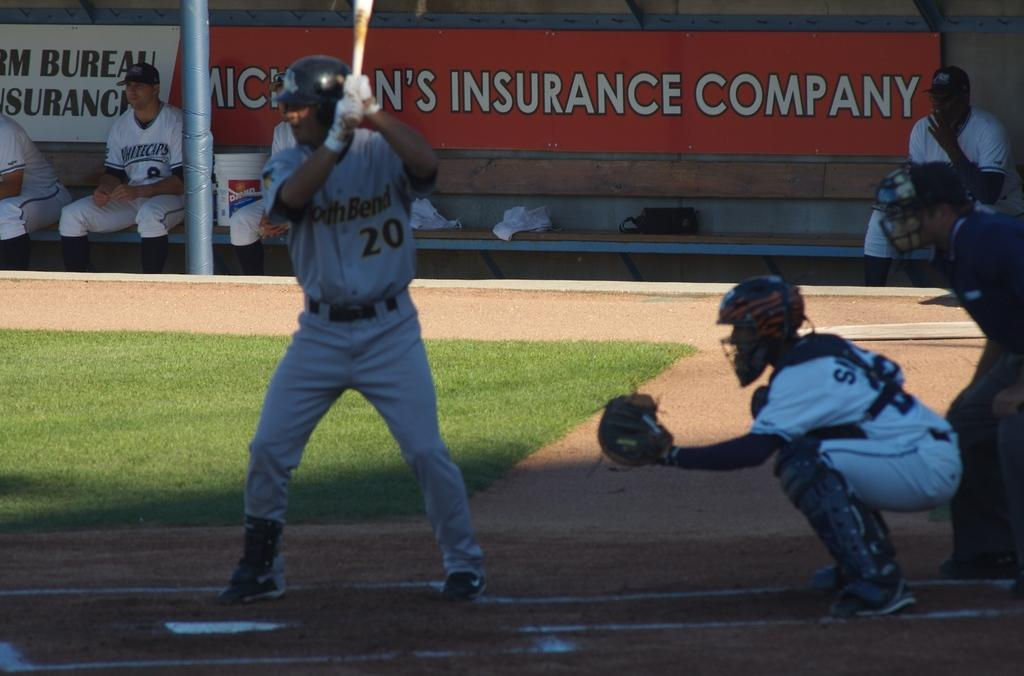<image>
Offer a succinct explanation of the picture presented. A NorthBend baseball player is ready at bat. 